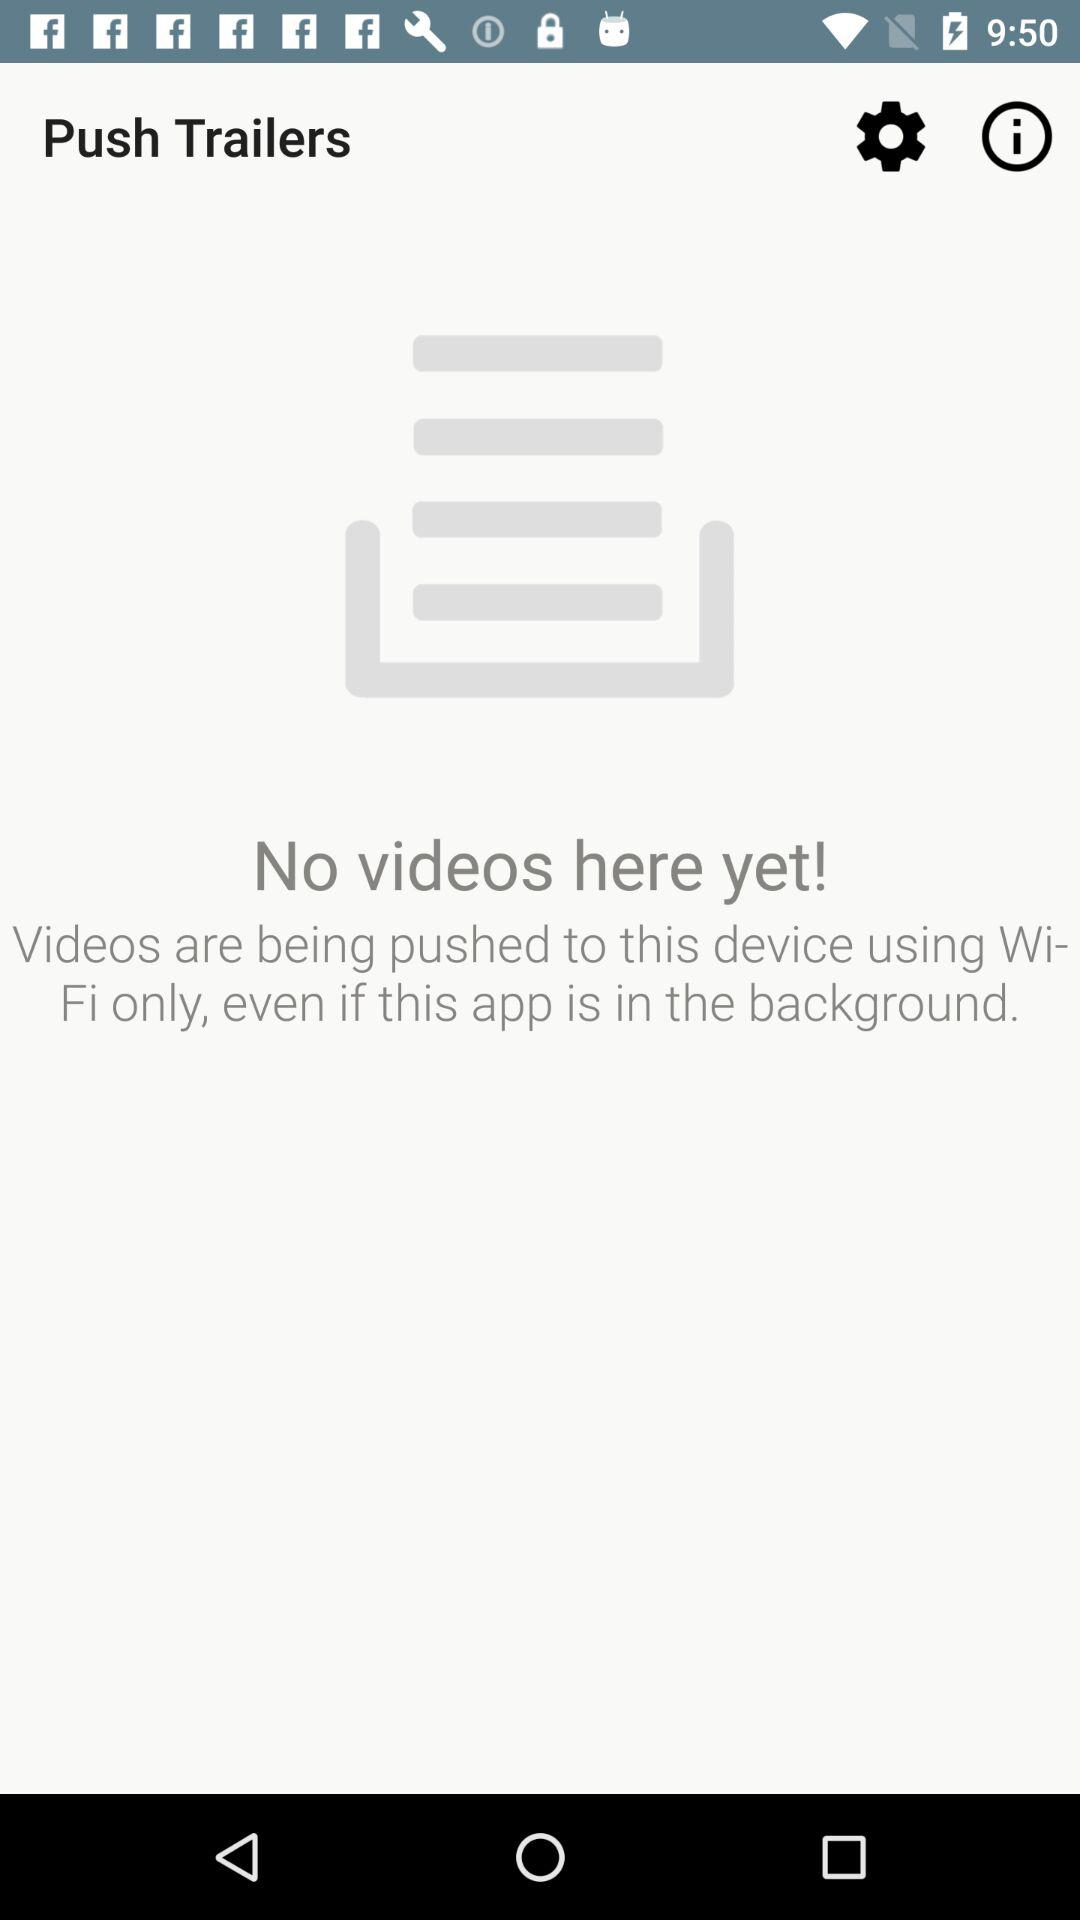Is there any video? There are no videos. 